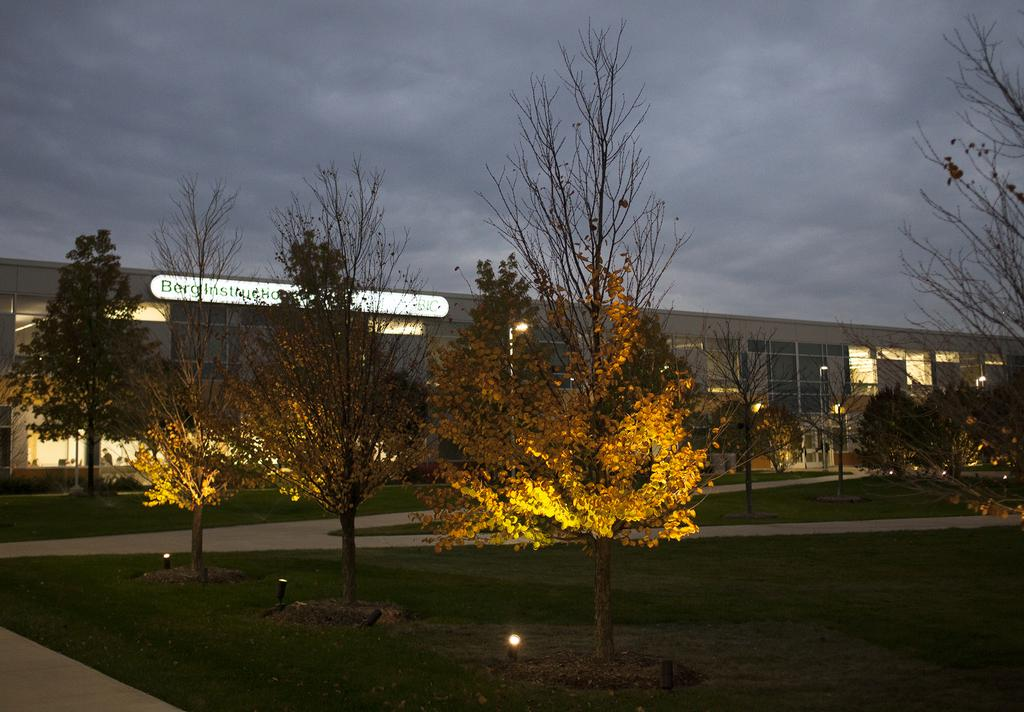What type of structure is visible in the image? There is a building in the image. What is located in front of the building? There are trees in front of the building. What type of lighting is present in the image? There are street lights and focus lights on the surface of the grass in the image. What can be seen in the background of the image? The sky is visible in the background of the image. Can you see any deer in the image? There are no deer present in the image. Is there a skateboard visible in the image? There is no skateboard present in the image. 